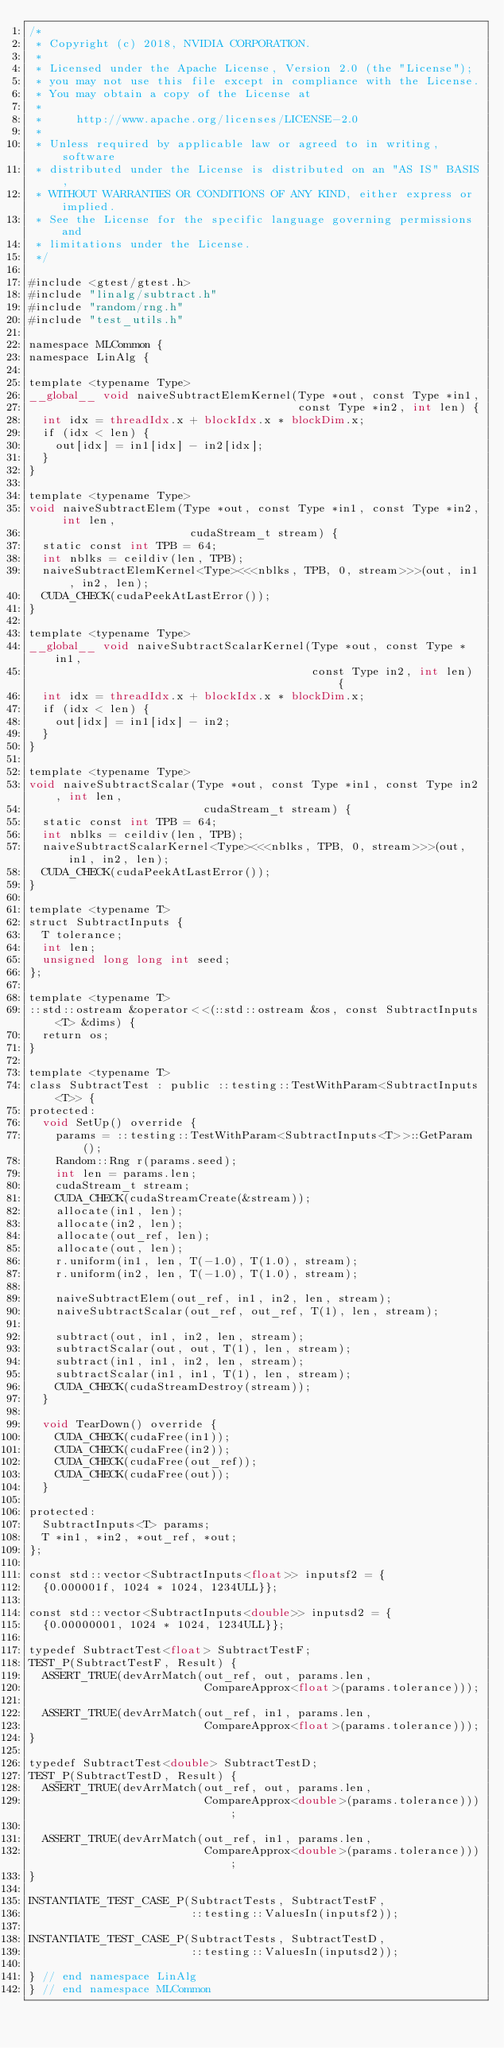Convert code to text. <code><loc_0><loc_0><loc_500><loc_500><_Cuda_>/*
 * Copyright (c) 2018, NVIDIA CORPORATION.
 *
 * Licensed under the Apache License, Version 2.0 (the "License");
 * you may not use this file except in compliance with the License.
 * You may obtain a copy of the License at
 *
 *     http://www.apache.org/licenses/LICENSE-2.0
 *
 * Unless required by applicable law or agreed to in writing, software
 * distributed under the License is distributed on an "AS IS" BASIS,
 * WITHOUT WARRANTIES OR CONDITIONS OF ANY KIND, either express or implied.
 * See the License for the specific language governing permissions and
 * limitations under the License.
 */

#include <gtest/gtest.h>
#include "linalg/subtract.h"
#include "random/rng.h"
#include "test_utils.h"

namespace MLCommon {
namespace LinAlg {

template <typename Type>
__global__ void naiveSubtractElemKernel(Type *out, const Type *in1,
                                        const Type *in2, int len) {
  int idx = threadIdx.x + blockIdx.x * blockDim.x;
  if (idx < len) {
    out[idx] = in1[idx] - in2[idx];
  }
}

template <typename Type>
void naiveSubtractElem(Type *out, const Type *in1, const Type *in2, int len,
                        cudaStream_t stream) {
  static const int TPB = 64;
  int nblks = ceildiv(len, TPB);
  naiveSubtractElemKernel<Type><<<nblks, TPB, 0, stream>>>(out, in1, in2, len);
  CUDA_CHECK(cudaPeekAtLastError());
}

template <typename Type>
__global__ void naiveSubtractScalarKernel(Type *out, const Type *in1,
                                          const Type in2, int len) {
  int idx = threadIdx.x + blockIdx.x * blockDim.x;
  if (idx < len) {
    out[idx] = in1[idx] - in2;
  }
}

template <typename Type>
void naiveSubtractScalar(Type *out, const Type *in1, const Type in2, int len,
                          cudaStream_t stream) {
  static const int TPB = 64;
  int nblks = ceildiv(len, TPB);
  naiveSubtractScalarKernel<Type><<<nblks, TPB, 0, stream>>>(out, in1, in2, len);
  CUDA_CHECK(cudaPeekAtLastError());
}

template <typename T>
struct SubtractInputs {
  T tolerance;
  int len;
  unsigned long long int seed;
};

template <typename T>
::std::ostream &operator<<(::std::ostream &os, const SubtractInputs<T> &dims) {
  return os;
}

template <typename T>
class SubtractTest : public ::testing::TestWithParam<SubtractInputs<T>> {
protected:
  void SetUp() override {
    params = ::testing::TestWithParam<SubtractInputs<T>>::GetParam();
    Random::Rng r(params.seed);
    int len = params.len;
    cudaStream_t stream;
    CUDA_CHECK(cudaStreamCreate(&stream));
    allocate(in1, len);
    allocate(in2, len);
    allocate(out_ref, len);
    allocate(out, len);
    r.uniform(in1, len, T(-1.0), T(1.0), stream);
    r.uniform(in2, len, T(-1.0), T(1.0), stream);

    naiveSubtractElem(out_ref, in1, in2, len, stream);
    naiveSubtractScalar(out_ref, out_ref, T(1), len, stream);

    subtract(out, in1, in2, len, stream);
    subtractScalar(out, out, T(1), len, stream);
    subtract(in1, in1, in2, len, stream);
    subtractScalar(in1, in1, T(1), len, stream);
    CUDA_CHECK(cudaStreamDestroy(stream));
  }

  void TearDown() override {
    CUDA_CHECK(cudaFree(in1));
    CUDA_CHECK(cudaFree(in2));
    CUDA_CHECK(cudaFree(out_ref));
    CUDA_CHECK(cudaFree(out));
  }

protected:
  SubtractInputs<T> params;
  T *in1, *in2, *out_ref, *out;
};

const std::vector<SubtractInputs<float>> inputsf2 = {
  {0.000001f, 1024 * 1024, 1234ULL}};

const std::vector<SubtractInputs<double>> inputsd2 = {
  {0.00000001, 1024 * 1024, 1234ULL}};

typedef SubtractTest<float> SubtractTestF;
TEST_P(SubtractTestF, Result) {
  ASSERT_TRUE(devArrMatch(out_ref, out, params.len,
                          CompareApprox<float>(params.tolerance)));

  ASSERT_TRUE(devArrMatch(out_ref, in1, params.len,
                          CompareApprox<float>(params.tolerance)));
}

typedef SubtractTest<double> SubtractTestD;
TEST_P(SubtractTestD, Result) {
  ASSERT_TRUE(devArrMatch(out_ref, out, params.len,
                          CompareApprox<double>(params.tolerance)));

  ASSERT_TRUE(devArrMatch(out_ref, in1, params.len,
                          CompareApprox<double>(params.tolerance)));
}

INSTANTIATE_TEST_CASE_P(SubtractTests, SubtractTestF,
                        ::testing::ValuesIn(inputsf2));

INSTANTIATE_TEST_CASE_P(SubtractTests, SubtractTestD,
                        ::testing::ValuesIn(inputsd2));

} // end namespace LinAlg
} // end namespace MLCommon
</code> 